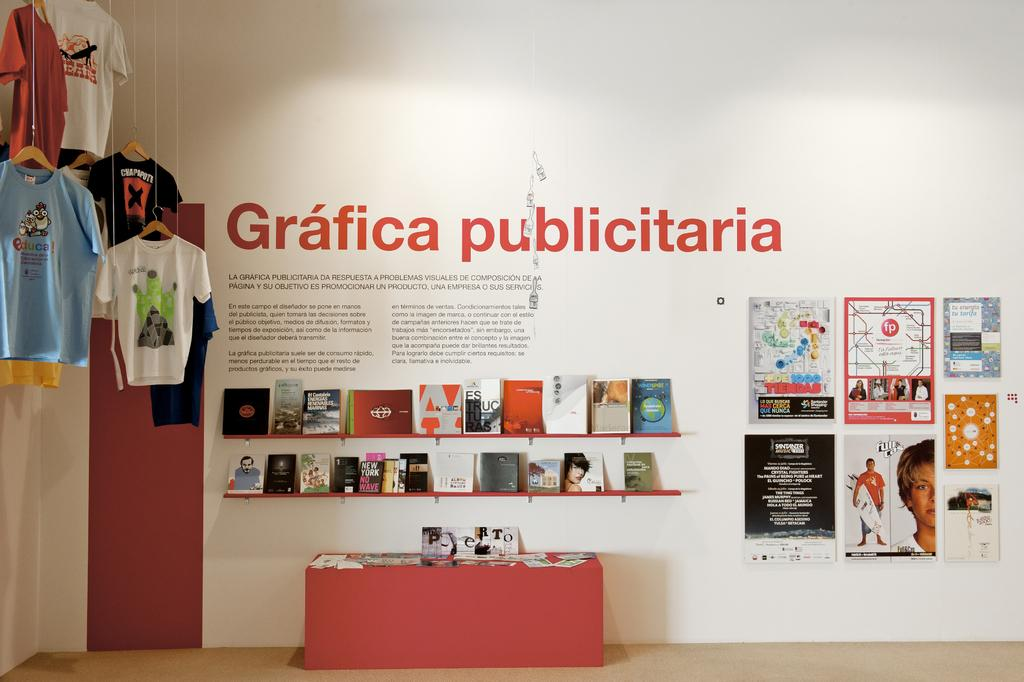<image>
Give a short and clear explanation of the subsequent image. A display of merchandise with a Grafica Publicitaria sign behind it. 